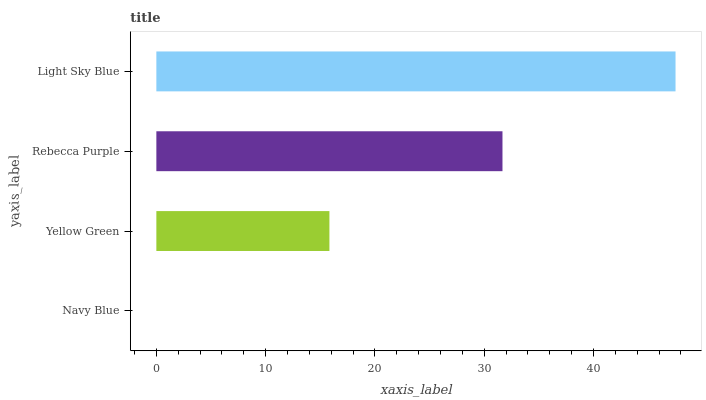Is Navy Blue the minimum?
Answer yes or no. Yes. Is Light Sky Blue the maximum?
Answer yes or no. Yes. Is Yellow Green the minimum?
Answer yes or no. No. Is Yellow Green the maximum?
Answer yes or no. No. Is Yellow Green greater than Navy Blue?
Answer yes or no. Yes. Is Navy Blue less than Yellow Green?
Answer yes or no. Yes. Is Navy Blue greater than Yellow Green?
Answer yes or no. No. Is Yellow Green less than Navy Blue?
Answer yes or no. No. Is Rebecca Purple the high median?
Answer yes or no. Yes. Is Yellow Green the low median?
Answer yes or no. Yes. Is Light Sky Blue the high median?
Answer yes or no. No. Is Light Sky Blue the low median?
Answer yes or no. No. 